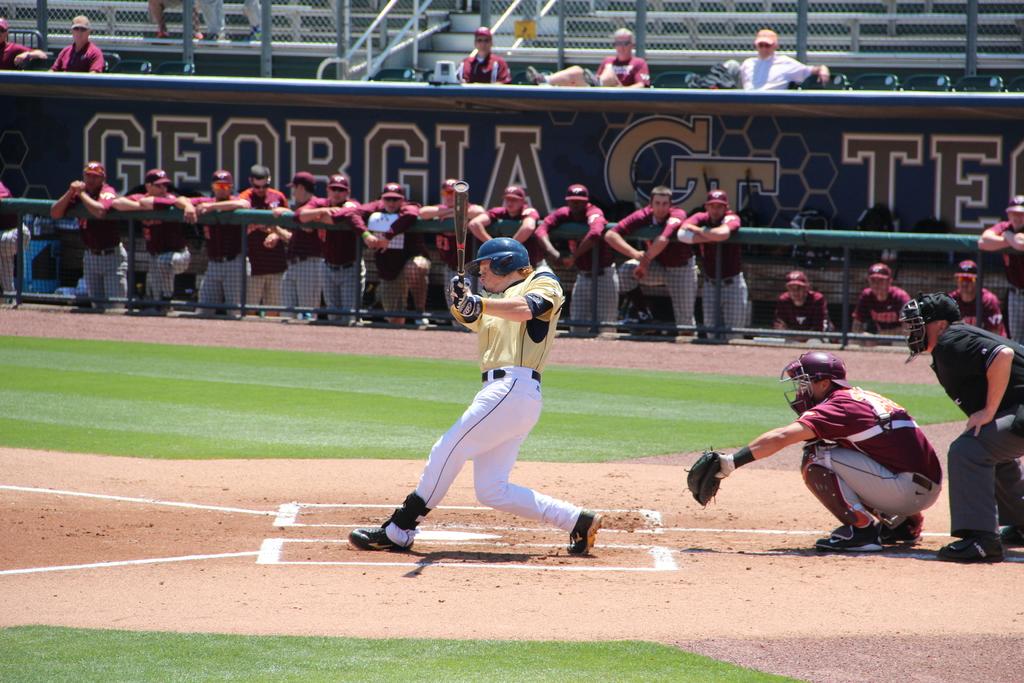What state is being played in?
Provide a short and direct response. Georgia. They are playing?
Provide a short and direct response. Answering does not require reading text in the image. 